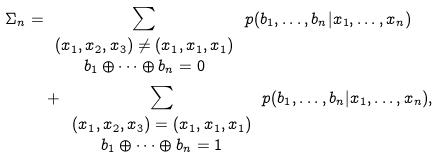Convert formula to latex. <formula><loc_0><loc_0><loc_500><loc_500>\Sigma _ { n } = & \sum _ { \begin{array} { c } ( x _ { 1 } , x _ { 2 } , x _ { 3 } ) \neq ( x _ { 1 } , x _ { 1 } , x _ { 1 } ) \\ b _ { 1 } \oplus \cdots \oplus b _ { n } = 0 \\ \end{array} } p ( b _ { 1 } , \dots , b _ { n } | x _ { 1 } , \dots , x _ { n } ) \\ & + \sum _ { \begin{array} { c } ( x _ { 1 } , x _ { 2 } , x _ { 3 } ) = ( x _ { 1 } , x _ { 1 } , x _ { 1 } ) \\ b _ { 1 } \oplus \cdots \oplus b _ { n } = 1 \\ \end{array} } p ( b _ { 1 } , \dots , b _ { n } | x _ { 1 } , \dots , x _ { n } ) ,</formula> 